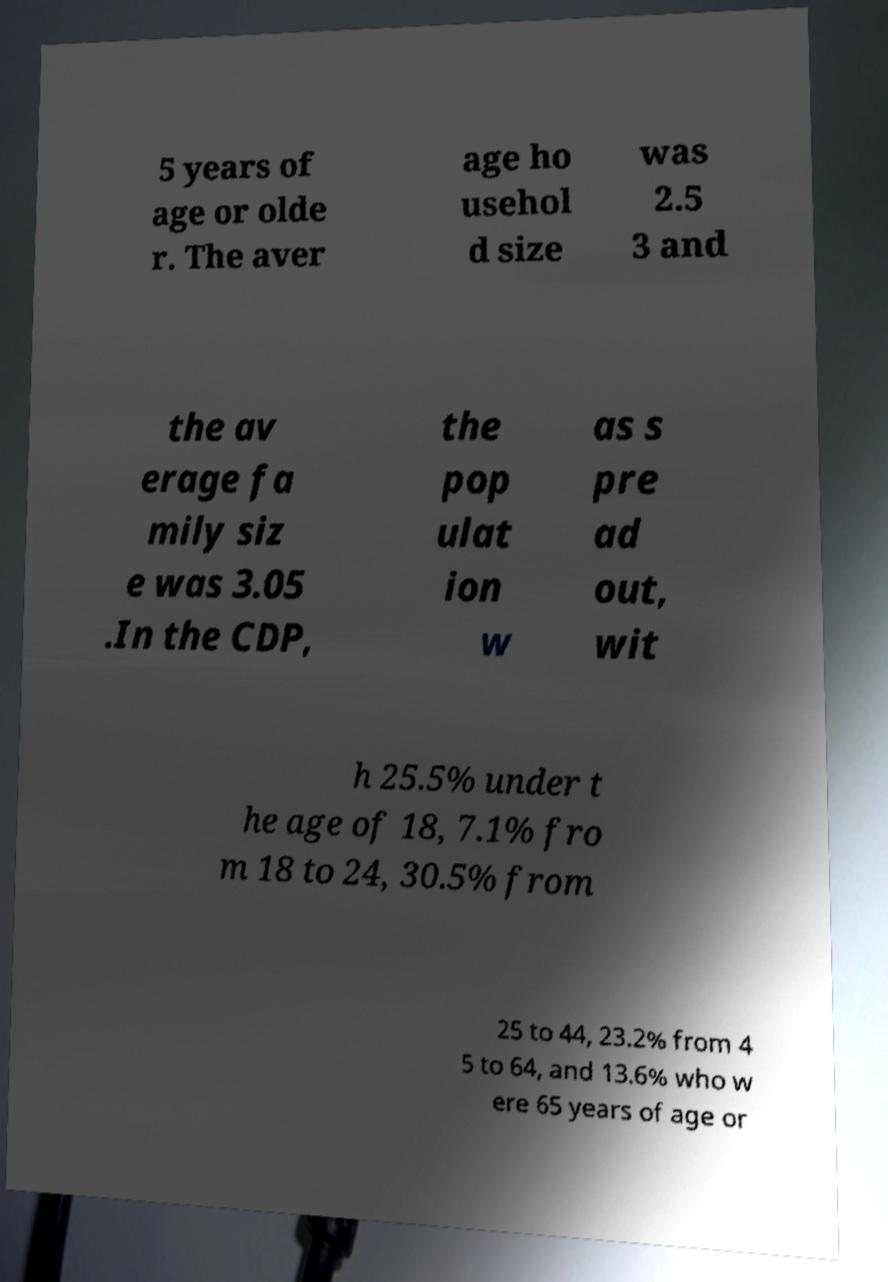There's text embedded in this image that I need extracted. Can you transcribe it verbatim? 5 years of age or olde r. The aver age ho usehol d size was 2.5 3 and the av erage fa mily siz e was 3.05 .In the CDP, the pop ulat ion w as s pre ad out, wit h 25.5% under t he age of 18, 7.1% fro m 18 to 24, 30.5% from 25 to 44, 23.2% from 4 5 to 64, and 13.6% who w ere 65 years of age or 